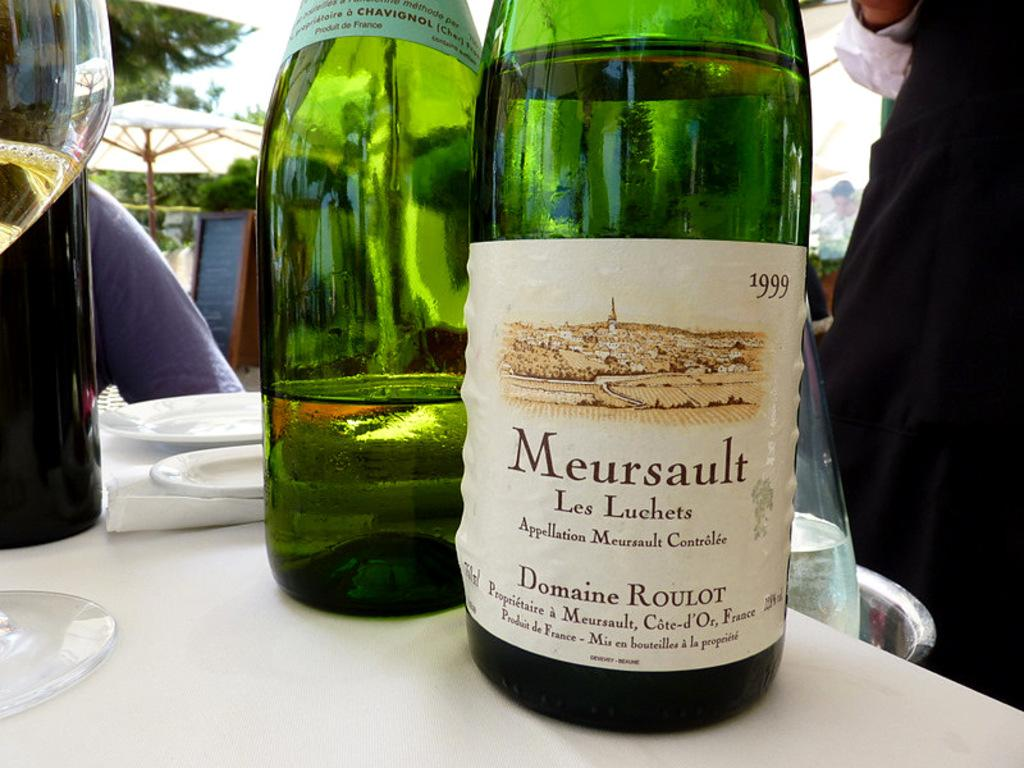Who or what can be seen in the image? There are people in the image. What are the people holding or using in the image? There are drink bottles in the image. What else is present on the table with the people and drink bottles? There are other objects on a table in the image. What can be seen providing shade or protection from the elements in the image? There is an umbrella in the image. What is visible in the background of the image? The sky is visible in the image. What letter is being written by the person in the image? There is no indication in the image that someone is writing a letter, so it cannot be determined from the picture. 